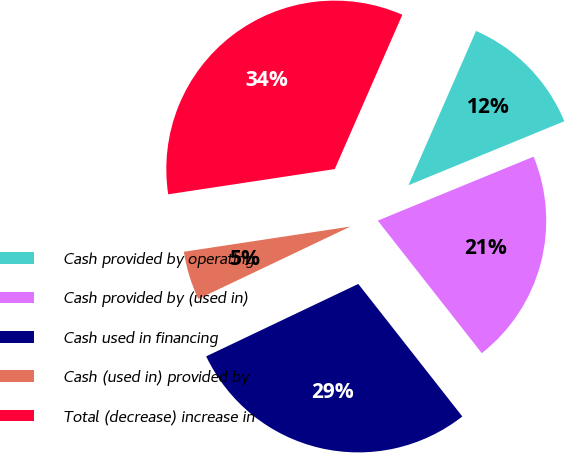Convert chart. <chart><loc_0><loc_0><loc_500><loc_500><pie_chart><fcel>Cash provided by operating<fcel>Cash provided by (used in)<fcel>Cash used in financing<fcel>Cash (used in) provided by<fcel>Total (decrease) increase in<nl><fcel>12.23%<fcel>20.61%<fcel>28.52%<fcel>4.68%<fcel>33.96%<nl></chart> 